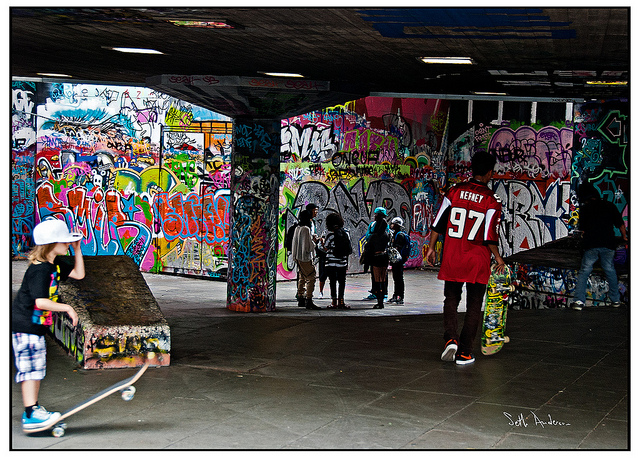Please transcribe the text information in this image. 971 MI5 